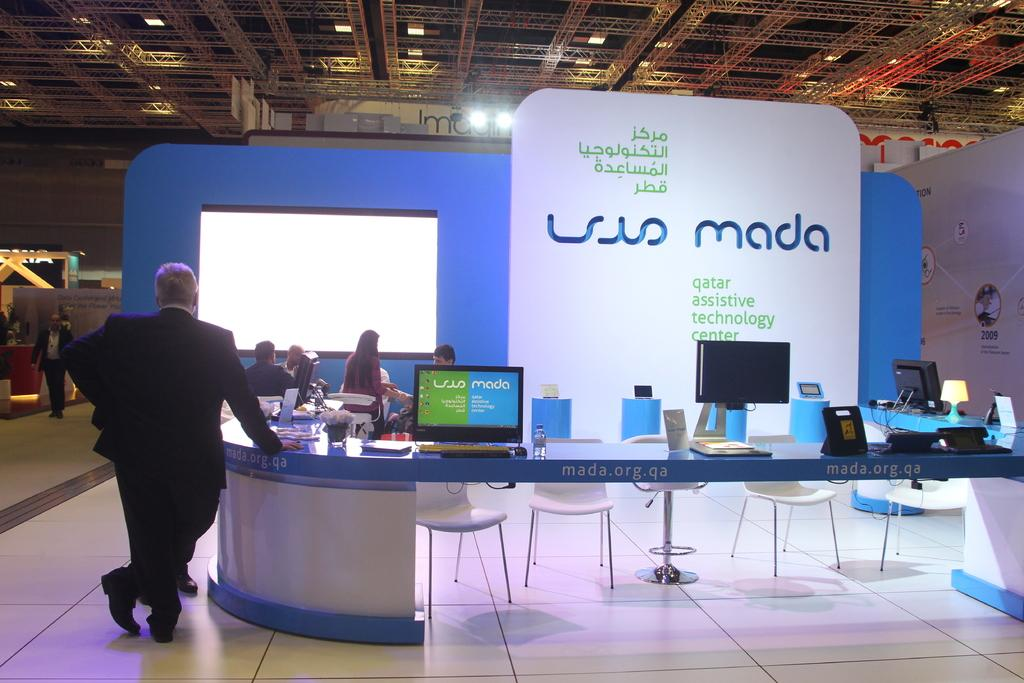What is the main subject of the image? There is a man standing in the image. What are the other people in the image doing? There are people seated in the image. What type of electronic devices can be seen in the image? There are monitors visible in the image. What type of furniture is present in the image? There are chairs in the image. What type of stitch is being used to sew the sofa in the image? There is no sofa present in the image, and therefore no stitching can be observed. What is the plot of the story unfolding in the image? There is no story or plot depicted in the image; it features people and monitors. 